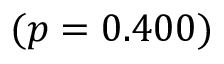Convert formula to latex. <formula><loc_0><loc_0><loc_500><loc_500>( p = 0 . 4 0 0 )</formula> 